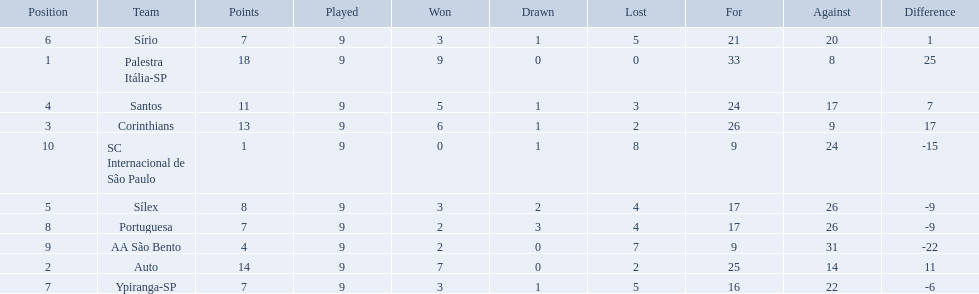What teams played in 1926? Palestra Itália-SP, Auto, Corinthians, Santos, Sílex, Sírio, Ypiranga-SP, Portuguesa, AA São Bento, SC Internacional de São Paulo. Did any team lose zero games? Palestra Itália-SP. How many games did each team play? 9, 9, 9, 9, 9, 9, 9, 9, 9, 9. Did any team score 13 points in the total games they played? 13. What is the name of that team? Corinthians. Help me parse the entirety of this table. {'header': ['Position', 'Team', 'Points', 'Played', 'Won', 'Drawn', 'Lost', 'For', 'Against', 'Difference'], 'rows': [['6', 'Sírio', '7', '9', '3', '1', '5', '21', '20', '1'], ['1', 'Palestra Itália-SP', '18', '9', '9', '0', '0', '33', '8', '25'], ['4', 'Santos', '11', '9', '5', '1', '3', '24', '17', '7'], ['3', 'Corinthians', '13', '9', '6', '1', '2', '26', '9', '17'], ['10', 'SC Internacional de São Paulo', '1', '9', '0', '1', '8', '9', '24', '-15'], ['5', 'Sílex', '8', '9', '3', '2', '4', '17', '26', '-9'], ['8', 'Portuguesa', '7', '9', '2', '3', '4', '17', '26', '-9'], ['9', 'AA São Bento', '4', '9', '2', '0', '7', '9', '31', '-22'], ['2', 'Auto', '14', '9', '7', '0', '2', '25', '14', '11'], ['7', 'Ypiranga-SP', '7', '9', '3', '1', '5', '16', '22', '-6']]} 